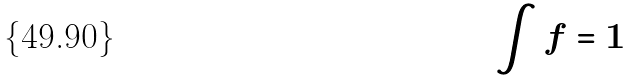Convert formula to latex. <formula><loc_0><loc_0><loc_500><loc_500>\int f = 1</formula> 